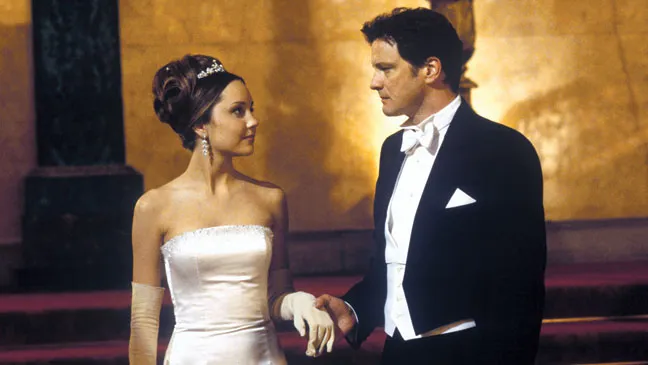Imagine if the setting was in a fantasy world. What roles would the characters play? In a fantastical realm, Amanda Bynes’ character could be the Princess of an ancient, magical kingdom, her attire reflecting her royal heritage and the mystical grace of her lineage. The tiara on her head could be enchanted, symbolizing her rightful place on the throne and her bond with the land's magical forces. Colin Firth's character might be a seasoned knight, dedicated to protecting the realm and serving the royal family. His serious demeanor could be due to the weight of his duty, perhaps guarding a powerful secret or grappling with an impending threat to the kingdom. This moment shared between them could be during a pivotal council meeting in the grand hall where they're planning a strategy to ward off an encroaching dark force, signifying their unity and resolve in the face of adversity. 